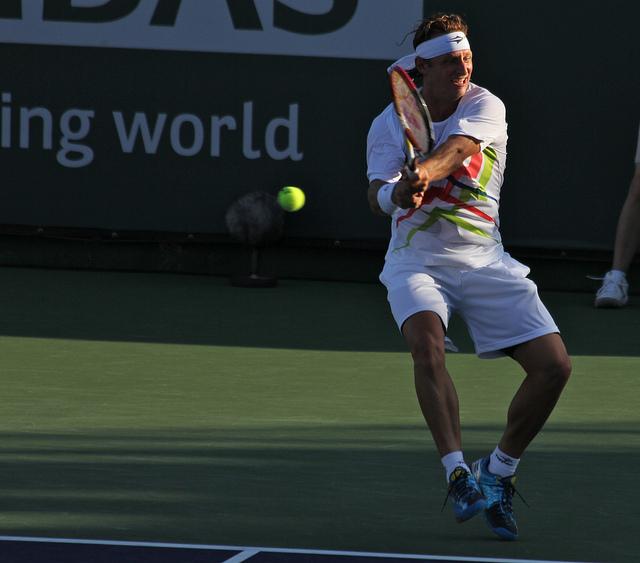Is the ball visible?
Answer briefly. Yes. What brand of socks is the man wearing?
Answer briefly. Nike. How many balls is this tennis player throwing up?
Keep it brief. 1. What color are the man's shoes?
Concise answer only. Blue. What is on the player's knee?
Keep it brief. Nothing. What court number is the man playing on?
Give a very brief answer. 1. Is this man in the middle or the side of the tennis field?
Concise answer only. Side. What emblem is on his headband, wristband and socks?
Keep it brief. Nike. What color are his socks?
Answer briefly. White. Is this an outdoor match?
Write a very short answer. Yes. Has the player already hit the ball?
Keep it brief. Yes. Are both elbows bent?
Give a very brief answer. No. What type of court material is this person playing tennis on?
Short answer required. Turf. Does the man have a lot of hair on his head?
Keep it brief. Yes. What color is the ball?
Keep it brief. Yellow. Is he wearing a visor?
Concise answer only. No. Is the man wearing a hat?
Quick response, please. No. What color is the court?
Quick response, please. Green. What color is the ball in mid air?
Keep it brief. Yellow. Is the tennis players shirt pulled up?
Keep it brief. No. What is on the man's face?
Quick response, please. Headband. What game are the men playing?
Write a very short answer. Tennis. Does the man have cats on his shirt?
Short answer required. No. 